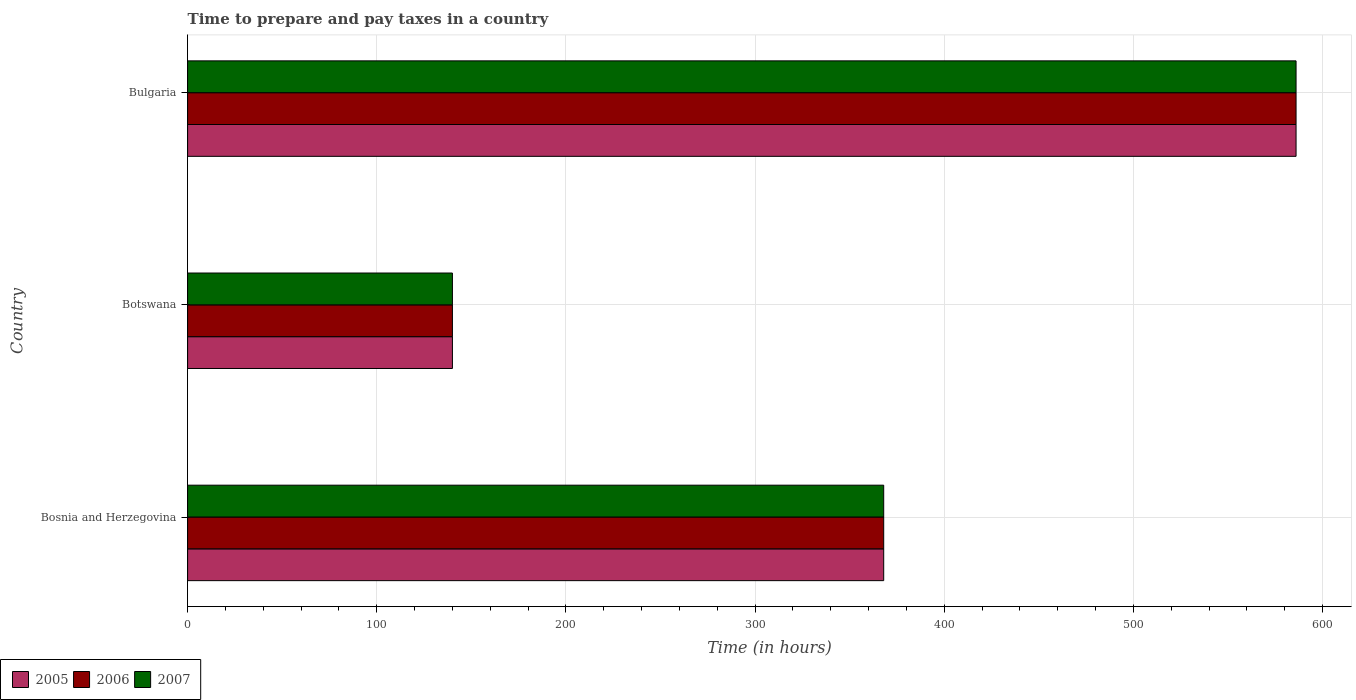How many different coloured bars are there?
Your answer should be compact. 3. Are the number of bars per tick equal to the number of legend labels?
Your response must be concise. Yes. How many bars are there on the 2nd tick from the bottom?
Offer a terse response. 3. What is the label of the 1st group of bars from the top?
Ensure brevity in your answer.  Bulgaria. In how many cases, is the number of bars for a given country not equal to the number of legend labels?
Give a very brief answer. 0. What is the number of hours required to prepare and pay taxes in 2005 in Botswana?
Ensure brevity in your answer.  140. Across all countries, what is the maximum number of hours required to prepare and pay taxes in 2007?
Ensure brevity in your answer.  586. Across all countries, what is the minimum number of hours required to prepare and pay taxes in 2005?
Offer a terse response. 140. In which country was the number of hours required to prepare and pay taxes in 2005 maximum?
Your answer should be compact. Bulgaria. In which country was the number of hours required to prepare and pay taxes in 2006 minimum?
Offer a terse response. Botswana. What is the total number of hours required to prepare and pay taxes in 2006 in the graph?
Make the answer very short. 1094. What is the difference between the number of hours required to prepare and pay taxes in 2006 in Bosnia and Herzegovina and that in Botswana?
Offer a very short reply. 228. What is the difference between the number of hours required to prepare and pay taxes in 2006 in Bosnia and Herzegovina and the number of hours required to prepare and pay taxes in 2007 in Botswana?
Provide a succinct answer. 228. What is the average number of hours required to prepare and pay taxes in 2005 per country?
Make the answer very short. 364.67. In how many countries, is the number of hours required to prepare and pay taxes in 2007 greater than 160 hours?
Keep it short and to the point. 2. What is the ratio of the number of hours required to prepare and pay taxes in 2005 in Bosnia and Herzegovina to that in Botswana?
Your response must be concise. 2.63. Is the number of hours required to prepare and pay taxes in 2006 in Botswana less than that in Bulgaria?
Offer a very short reply. Yes. Is the difference between the number of hours required to prepare and pay taxes in 2006 in Bosnia and Herzegovina and Bulgaria greater than the difference between the number of hours required to prepare and pay taxes in 2005 in Bosnia and Herzegovina and Bulgaria?
Provide a succinct answer. No. What is the difference between the highest and the second highest number of hours required to prepare and pay taxes in 2006?
Your answer should be very brief. 218. What is the difference between the highest and the lowest number of hours required to prepare and pay taxes in 2007?
Your response must be concise. 446. How many bars are there?
Offer a terse response. 9. What is the difference between two consecutive major ticks on the X-axis?
Keep it short and to the point. 100. Where does the legend appear in the graph?
Give a very brief answer. Bottom left. How many legend labels are there?
Offer a terse response. 3. What is the title of the graph?
Your answer should be compact. Time to prepare and pay taxes in a country. What is the label or title of the X-axis?
Your answer should be compact. Time (in hours). What is the Time (in hours) of 2005 in Bosnia and Herzegovina?
Keep it short and to the point. 368. What is the Time (in hours) in 2006 in Bosnia and Herzegovina?
Make the answer very short. 368. What is the Time (in hours) in 2007 in Bosnia and Herzegovina?
Ensure brevity in your answer.  368. What is the Time (in hours) in 2005 in Botswana?
Your answer should be compact. 140. What is the Time (in hours) in 2006 in Botswana?
Provide a succinct answer. 140. What is the Time (in hours) in 2007 in Botswana?
Your answer should be compact. 140. What is the Time (in hours) in 2005 in Bulgaria?
Offer a very short reply. 586. What is the Time (in hours) in 2006 in Bulgaria?
Your answer should be compact. 586. What is the Time (in hours) of 2007 in Bulgaria?
Ensure brevity in your answer.  586. Across all countries, what is the maximum Time (in hours) of 2005?
Your answer should be very brief. 586. Across all countries, what is the maximum Time (in hours) of 2006?
Ensure brevity in your answer.  586. Across all countries, what is the maximum Time (in hours) in 2007?
Offer a terse response. 586. Across all countries, what is the minimum Time (in hours) in 2005?
Give a very brief answer. 140. Across all countries, what is the minimum Time (in hours) of 2006?
Keep it short and to the point. 140. Across all countries, what is the minimum Time (in hours) of 2007?
Offer a very short reply. 140. What is the total Time (in hours) of 2005 in the graph?
Provide a short and direct response. 1094. What is the total Time (in hours) in 2006 in the graph?
Keep it short and to the point. 1094. What is the total Time (in hours) of 2007 in the graph?
Keep it short and to the point. 1094. What is the difference between the Time (in hours) in 2005 in Bosnia and Herzegovina and that in Botswana?
Give a very brief answer. 228. What is the difference between the Time (in hours) in 2006 in Bosnia and Herzegovina and that in Botswana?
Ensure brevity in your answer.  228. What is the difference between the Time (in hours) of 2007 in Bosnia and Herzegovina and that in Botswana?
Keep it short and to the point. 228. What is the difference between the Time (in hours) in 2005 in Bosnia and Herzegovina and that in Bulgaria?
Provide a succinct answer. -218. What is the difference between the Time (in hours) in 2006 in Bosnia and Herzegovina and that in Bulgaria?
Your answer should be compact. -218. What is the difference between the Time (in hours) of 2007 in Bosnia and Herzegovina and that in Bulgaria?
Make the answer very short. -218. What is the difference between the Time (in hours) in 2005 in Botswana and that in Bulgaria?
Ensure brevity in your answer.  -446. What is the difference between the Time (in hours) of 2006 in Botswana and that in Bulgaria?
Offer a terse response. -446. What is the difference between the Time (in hours) of 2007 in Botswana and that in Bulgaria?
Make the answer very short. -446. What is the difference between the Time (in hours) of 2005 in Bosnia and Herzegovina and the Time (in hours) of 2006 in Botswana?
Provide a short and direct response. 228. What is the difference between the Time (in hours) of 2005 in Bosnia and Herzegovina and the Time (in hours) of 2007 in Botswana?
Provide a succinct answer. 228. What is the difference between the Time (in hours) in 2006 in Bosnia and Herzegovina and the Time (in hours) in 2007 in Botswana?
Keep it short and to the point. 228. What is the difference between the Time (in hours) in 2005 in Bosnia and Herzegovina and the Time (in hours) in 2006 in Bulgaria?
Keep it short and to the point. -218. What is the difference between the Time (in hours) of 2005 in Bosnia and Herzegovina and the Time (in hours) of 2007 in Bulgaria?
Provide a succinct answer. -218. What is the difference between the Time (in hours) of 2006 in Bosnia and Herzegovina and the Time (in hours) of 2007 in Bulgaria?
Your answer should be very brief. -218. What is the difference between the Time (in hours) of 2005 in Botswana and the Time (in hours) of 2006 in Bulgaria?
Offer a very short reply. -446. What is the difference between the Time (in hours) in 2005 in Botswana and the Time (in hours) in 2007 in Bulgaria?
Ensure brevity in your answer.  -446. What is the difference between the Time (in hours) in 2006 in Botswana and the Time (in hours) in 2007 in Bulgaria?
Offer a terse response. -446. What is the average Time (in hours) of 2005 per country?
Give a very brief answer. 364.67. What is the average Time (in hours) of 2006 per country?
Ensure brevity in your answer.  364.67. What is the average Time (in hours) in 2007 per country?
Ensure brevity in your answer.  364.67. What is the difference between the Time (in hours) of 2006 and Time (in hours) of 2007 in Bosnia and Herzegovina?
Offer a very short reply. 0. What is the difference between the Time (in hours) of 2005 and Time (in hours) of 2006 in Botswana?
Offer a very short reply. 0. What is the difference between the Time (in hours) in 2005 and Time (in hours) in 2007 in Botswana?
Provide a succinct answer. 0. What is the difference between the Time (in hours) of 2006 and Time (in hours) of 2007 in Botswana?
Provide a short and direct response. 0. What is the difference between the Time (in hours) in 2005 and Time (in hours) in 2006 in Bulgaria?
Keep it short and to the point. 0. What is the difference between the Time (in hours) in 2005 and Time (in hours) in 2007 in Bulgaria?
Your response must be concise. 0. What is the difference between the Time (in hours) in 2006 and Time (in hours) in 2007 in Bulgaria?
Your answer should be very brief. 0. What is the ratio of the Time (in hours) of 2005 in Bosnia and Herzegovina to that in Botswana?
Ensure brevity in your answer.  2.63. What is the ratio of the Time (in hours) of 2006 in Bosnia and Herzegovina to that in Botswana?
Give a very brief answer. 2.63. What is the ratio of the Time (in hours) of 2007 in Bosnia and Herzegovina to that in Botswana?
Provide a succinct answer. 2.63. What is the ratio of the Time (in hours) in 2005 in Bosnia and Herzegovina to that in Bulgaria?
Make the answer very short. 0.63. What is the ratio of the Time (in hours) of 2006 in Bosnia and Herzegovina to that in Bulgaria?
Your answer should be very brief. 0.63. What is the ratio of the Time (in hours) of 2007 in Bosnia and Herzegovina to that in Bulgaria?
Offer a very short reply. 0.63. What is the ratio of the Time (in hours) of 2005 in Botswana to that in Bulgaria?
Make the answer very short. 0.24. What is the ratio of the Time (in hours) of 2006 in Botswana to that in Bulgaria?
Provide a short and direct response. 0.24. What is the ratio of the Time (in hours) in 2007 in Botswana to that in Bulgaria?
Keep it short and to the point. 0.24. What is the difference between the highest and the second highest Time (in hours) in 2005?
Give a very brief answer. 218. What is the difference between the highest and the second highest Time (in hours) in 2006?
Your response must be concise. 218. What is the difference between the highest and the second highest Time (in hours) in 2007?
Offer a terse response. 218. What is the difference between the highest and the lowest Time (in hours) of 2005?
Make the answer very short. 446. What is the difference between the highest and the lowest Time (in hours) of 2006?
Offer a very short reply. 446. What is the difference between the highest and the lowest Time (in hours) of 2007?
Offer a terse response. 446. 